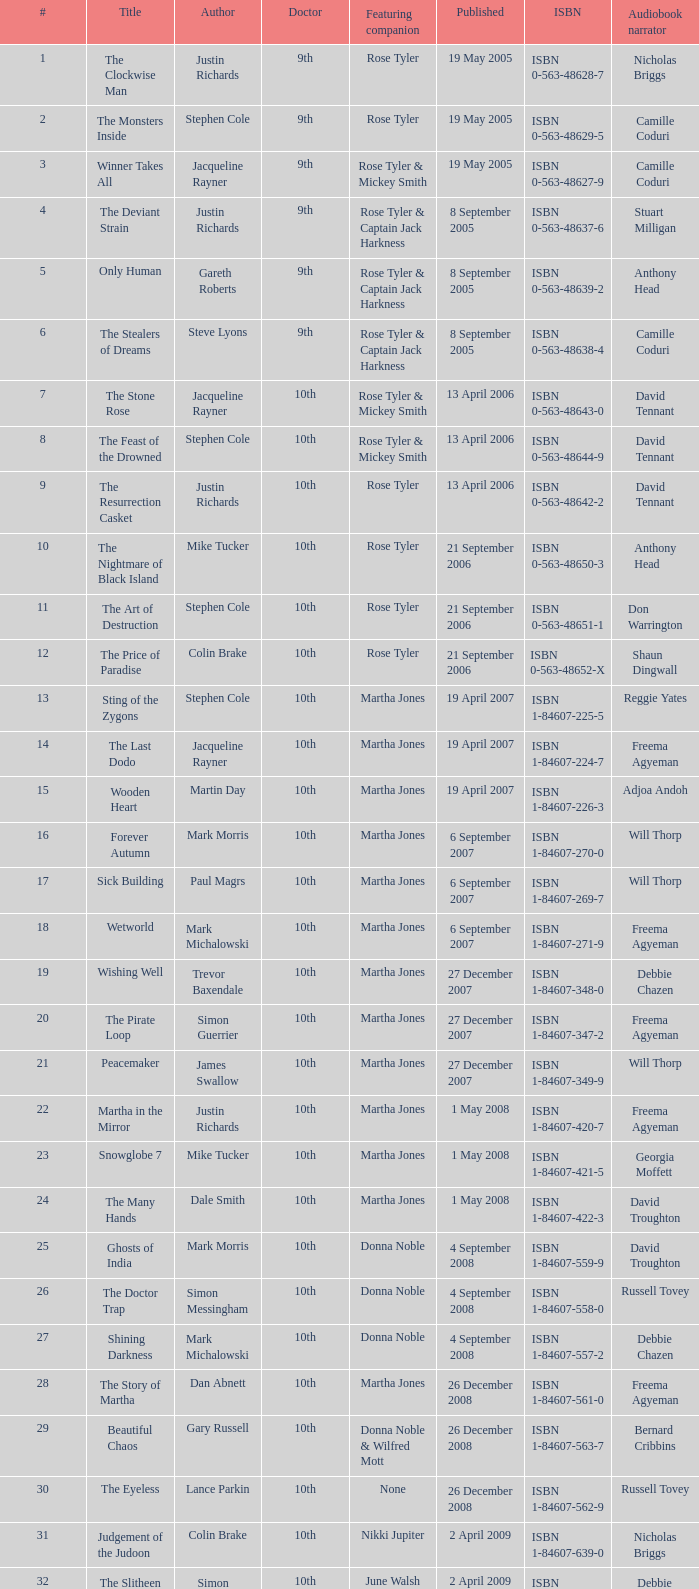Who are the collaborating companions linked to number 3? Rose Tyler & Mickey Smith. 